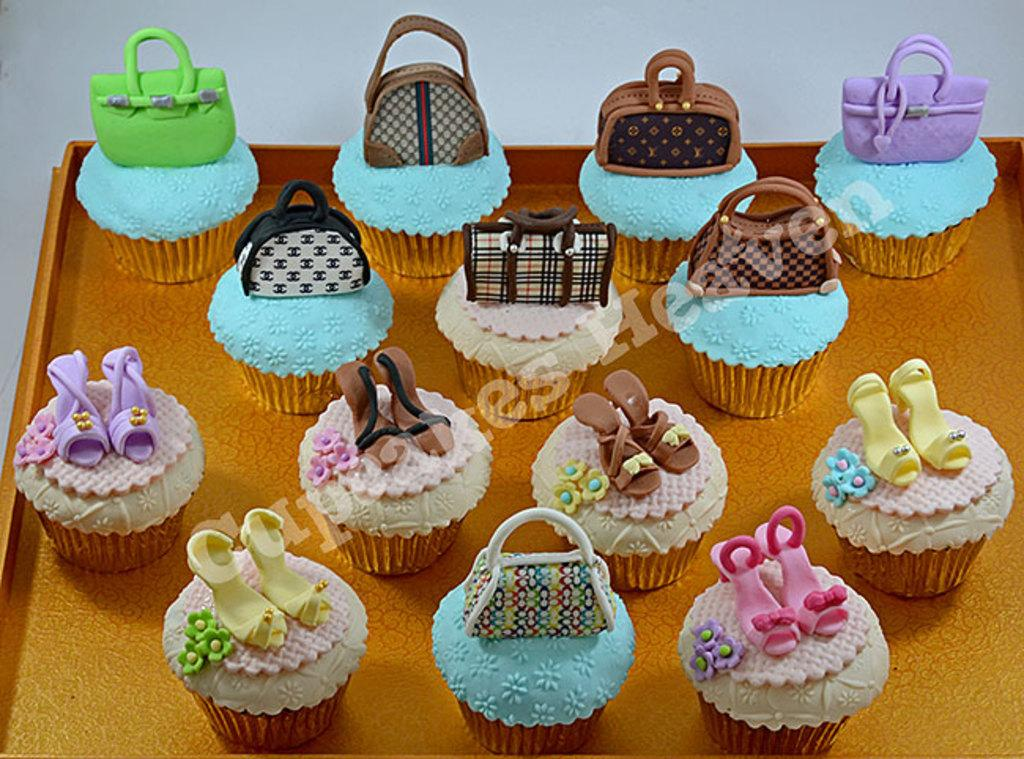What object is present in the image that can hold items? There is a tray in the image that can hold items. What type of food can be seen on the tray? The tray contains cupcakes. What type of metal is the tray made of in the image? The facts provided do not mention the material of the tray, so it cannot be determined from the image. 